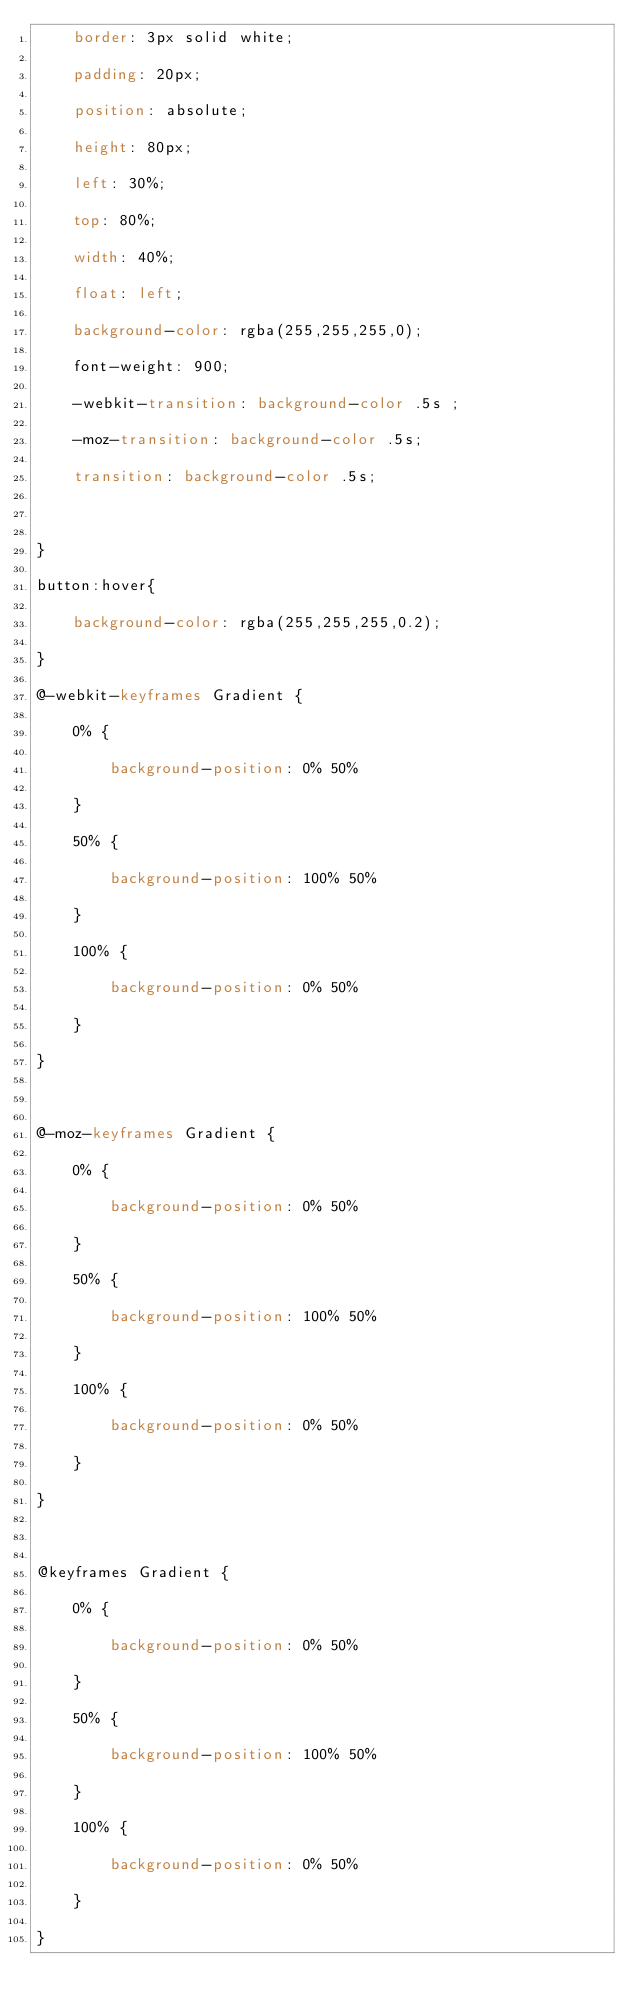Convert code to text. <code><loc_0><loc_0><loc_500><loc_500><_CSS_>	border: 3px solid white;
	padding: 20px;
	position: absolute;
	height: 80px;
	left: 30%;
	top: 80%;
	width: 40%;
	float: left;
	background-color: rgba(255,255,255,0);
	font-weight: 900;
	-webkit-transition: background-color .5s ;
	-moz-transition: background-color .5s;
	transition: background-color .5s;
	
}
button:hover{
	background-color: rgba(255,255,255,0.2);
}
@-webkit-keyframes Gradient {
	0% {
		background-position: 0% 50%
	}
	50% {
		background-position: 100% 50%
	}
	100% {
		background-position: 0% 50%
	}
}

@-moz-keyframes Gradient {
	0% {
		background-position: 0% 50%
	}
	50% {
		background-position: 100% 50%
	}
	100% {
		background-position: 0% 50%
	}
}

@keyframes Gradient {
	0% {
		background-position: 0% 50%
	}
	50% {
		background-position: 100% 50%
	}
	100% {
		background-position: 0% 50%
	}
}
</code> 